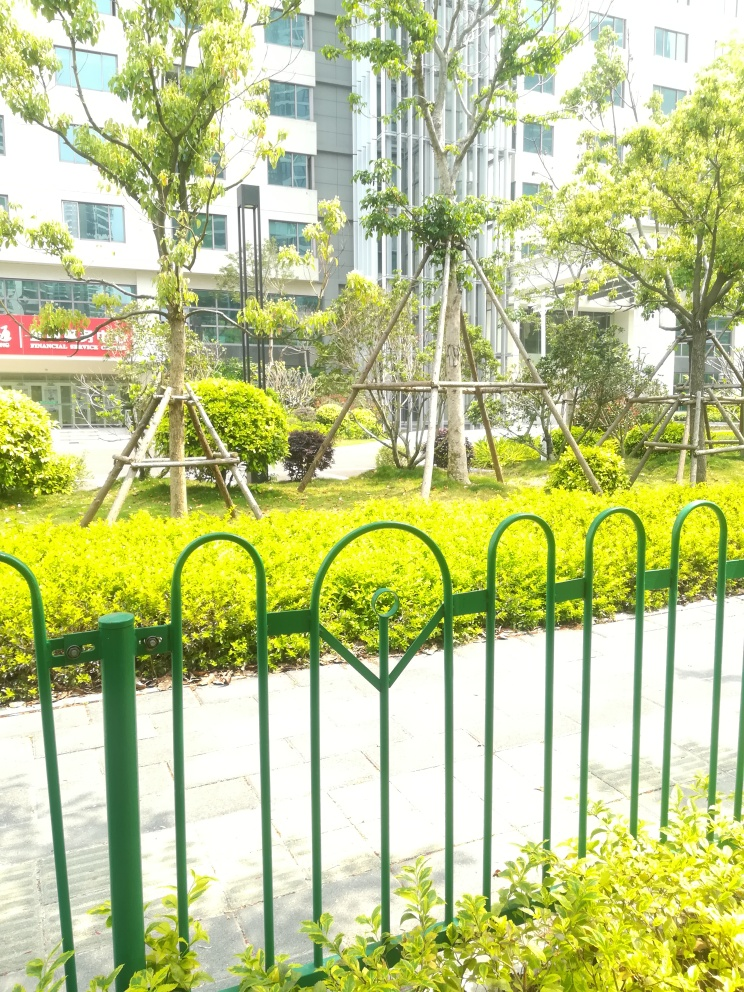Is the subject of the photo clear?
A. No
B. Yes
C. Uncertain
D. Blurred
Answer with the option's letter from the given choices directly.
 B. 